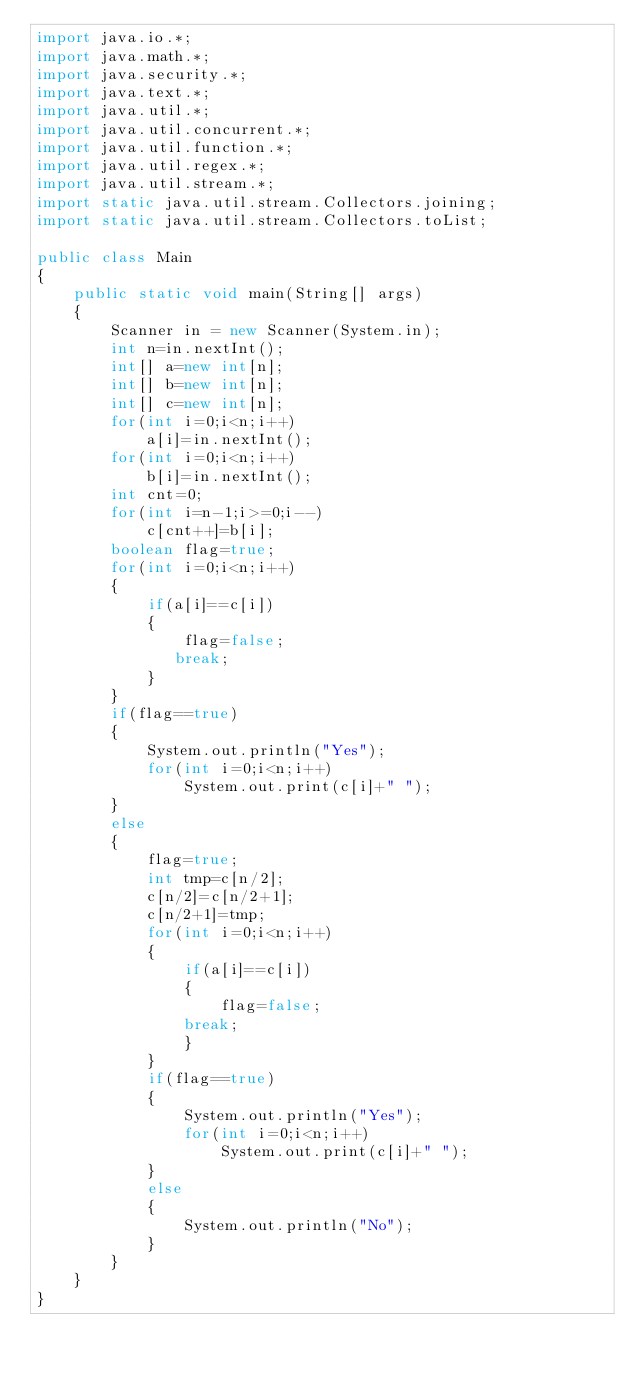Convert code to text. <code><loc_0><loc_0><loc_500><loc_500><_Java_>import java.io.*;
import java.math.*;
import java.security.*;
import java.text.*;
import java.util.*;
import java.util.concurrent.*;
import java.util.function.*;
import java.util.regex.*;
import java.util.stream.*;
import static java.util.stream.Collectors.joining;
import static java.util.stream.Collectors.toList;

public class Main
{
    public static void main(String[] args)
    {
        Scanner in = new Scanner(System.in);
        int n=in.nextInt();
        int[] a=new int[n];
        int[] b=new int[n];
        int[] c=new int[n];
        for(int i=0;i<n;i++)
            a[i]=in.nextInt();
        for(int i=0;i<n;i++)
            b[i]=in.nextInt();
        int cnt=0;
        for(int i=n-1;i>=0;i--)
            c[cnt++]=b[i];
        boolean flag=true;
        for(int i=0;i<n;i++)
        {
            if(a[i]==c[i])
            {
                flag=false;
               break; 
            }
        }
        if(flag==true)
        {
            System.out.println("Yes");
            for(int i=0;i<n;i++)
                System.out.print(c[i]+" ");
        }
        else
        {
            flag=true;
            int tmp=c[n/2];
            c[n/2]=c[n/2+1];
            c[n/2+1]=tmp;
            for(int i=0;i<n;i++)
            {
                if(a[i]==c[i])
                {
                    flag=false;
                break; 
                }
            }
            if(flag==true)
            {
                System.out.println("Yes");
                for(int i=0;i<n;i++)
                    System.out.print(c[i]+" ");
            }
            else
            {
                System.out.println("No");
            }
        }
    }
}</code> 